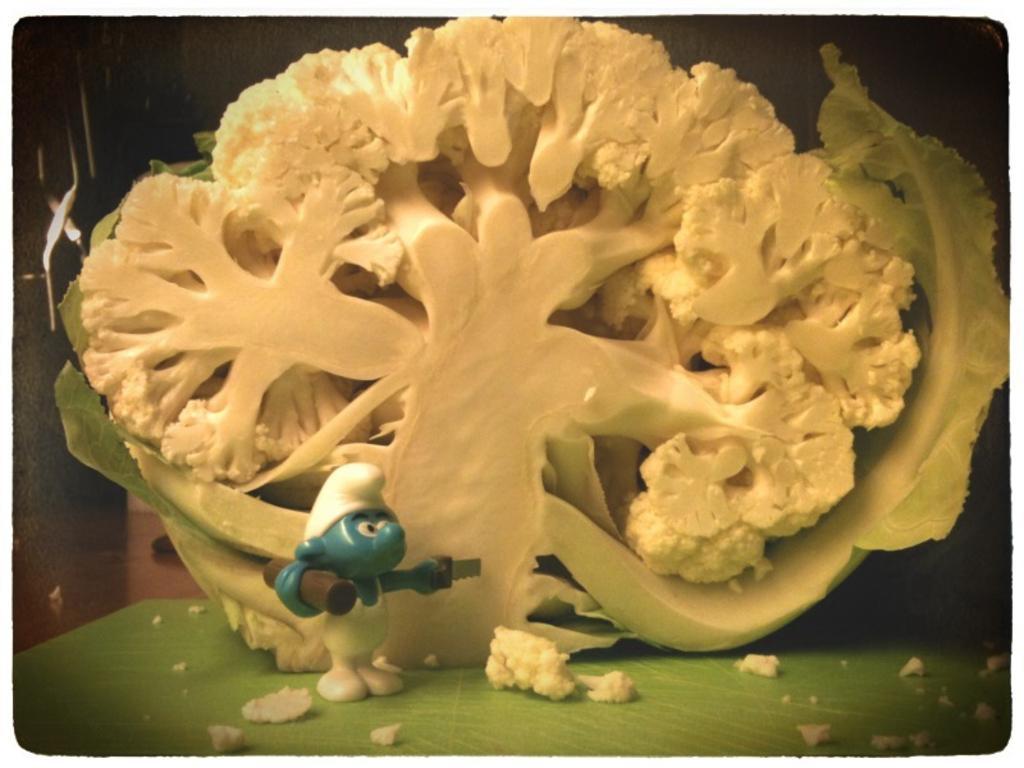Describe this image in one or two sentences. In this image, we can see a white color vegetable and there is a small plastic toy. 